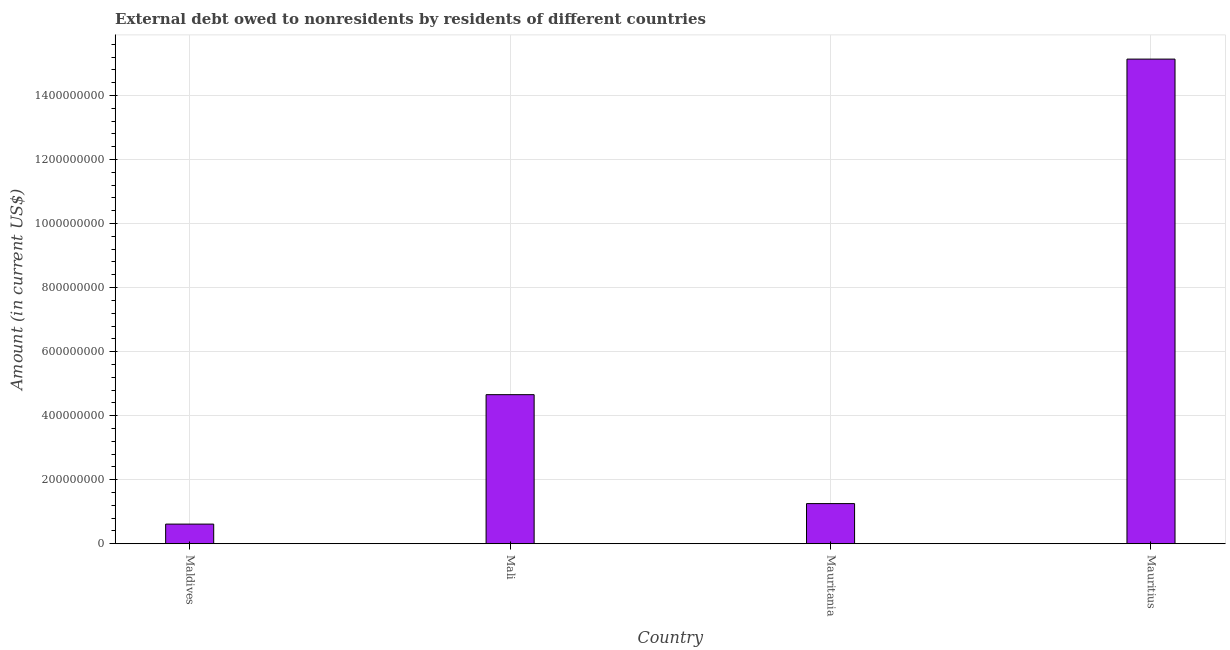Does the graph contain any zero values?
Give a very brief answer. No. What is the title of the graph?
Provide a short and direct response. External debt owed to nonresidents by residents of different countries. What is the label or title of the X-axis?
Offer a terse response. Country. What is the debt in Mauritius?
Make the answer very short. 1.51e+09. Across all countries, what is the maximum debt?
Your answer should be compact. 1.51e+09. Across all countries, what is the minimum debt?
Provide a succinct answer. 6.14e+07. In which country was the debt maximum?
Your answer should be compact. Mauritius. In which country was the debt minimum?
Offer a terse response. Maldives. What is the sum of the debt?
Offer a very short reply. 2.17e+09. What is the difference between the debt in Maldives and Mauritius?
Keep it short and to the point. -1.45e+09. What is the average debt per country?
Your answer should be compact. 5.41e+08. What is the median debt?
Keep it short and to the point. 2.95e+08. What is the ratio of the debt in Mauritania to that in Mauritius?
Ensure brevity in your answer.  0.08. Is the debt in Maldives less than that in Mali?
Your answer should be compact. Yes. What is the difference between the highest and the second highest debt?
Give a very brief answer. 1.05e+09. Is the sum of the debt in Mauritania and Mauritius greater than the maximum debt across all countries?
Ensure brevity in your answer.  Yes. What is the difference between the highest and the lowest debt?
Your answer should be very brief. 1.45e+09. In how many countries, is the debt greater than the average debt taken over all countries?
Your answer should be compact. 1. Are all the bars in the graph horizontal?
Provide a short and direct response. No. How many countries are there in the graph?
Provide a short and direct response. 4. What is the difference between two consecutive major ticks on the Y-axis?
Offer a very short reply. 2.00e+08. Are the values on the major ticks of Y-axis written in scientific E-notation?
Make the answer very short. No. What is the Amount (in current US$) of Maldives?
Your answer should be very brief. 6.14e+07. What is the Amount (in current US$) of Mali?
Your answer should be very brief. 4.66e+08. What is the Amount (in current US$) in Mauritania?
Give a very brief answer. 1.25e+08. What is the Amount (in current US$) in Mauritius?
Provide a succinct answer. 1.51e+09. What is the difference between the Amount (in current US$) in Maldives and Mali?
Give a very brief answer. -4.04e+08. What is the difference between the Amount (in current US$) in Maldives and Mauritania?
Offer a very short reply. -6.40e+07. What is the difference between the Amount (in current US$) in Maldives and Mauritius?
Offer a very short reply. -1.45e+09. What is the difference between the Amount (in current US$) in Mali and Mauritania?
Make the answer very short. 3.40e+08. What is the difference between the Amount (in current US$) in Mali and Mauritius?
Your answer should be compact. -1.05e+09. What is the difference between the Amount (in current US$) in Mauritania and Mauritius?
Keep it short and to the point. -1.39e+09. What is the ratio of the Amount (in current US$) in Maldives to that in Mali?
Keep it short and to the point. 0.13. What is the ratio of the Amount (in current US$) in Maldives to that in Mauritania?
Offer a terse response. 0.49. What is the ratio of the Amount (in current US$) in Maldives to that in Mauritius?
Provide a short and direct response. 0.04. What is the ratio of the Amount (in current US$) in Mali to that in Mauritania?
Offer a very short reply. 3.71. What is the ratio of the Amount (in current US$) in Mali to that in Mauritius?
Keep it short and to the point. 0.31. What is the ratio of the Amount (in current US$) in Mauritania to that in Mauritius?
Ensure brevity in your answer.  0.08. 